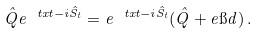Convert formula to latex. <formula><loc_0><loc_0><loc_500><loc_500>\hat { Q } e ^ { \ t x t - i \hat { S } _ { t } } = e ^ { \ t x t - i \hat { S } _ { t } } ( \hat { Q } + e \i d ) \, .</formula> 